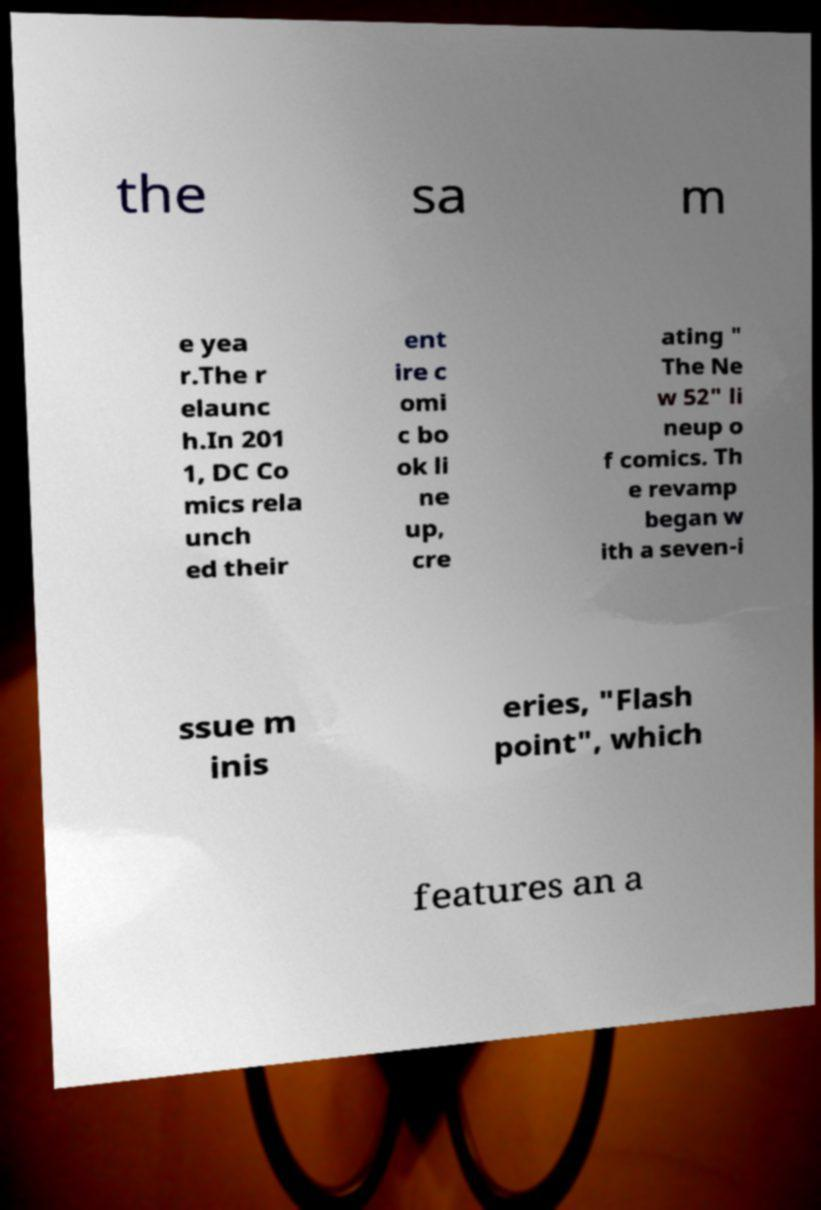There's text embedded in this image that I need extracted. Can you transcribe it verbatim? the sa m e yea r.The r elaunc h.In 201 1, DC Co mics rela unch ed their ent ire c omi c bo ok li ne up, cre ating " The Ne w 52" li neup o f comics. Th e revamp began w ith a seven-i ssue m inis eries, "Flash point", which features an a 